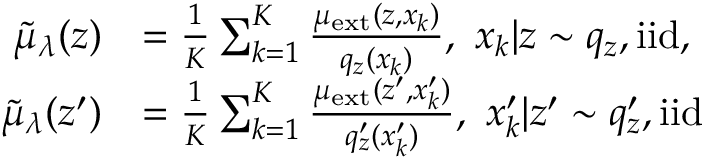<formula> <loc_0><loc_0><loc_500><loc_500>\begin{array} { r l } { \tilde { \mu } _ { \lambda } ( z ) } & { = \frac { 1 } { K } \sum _ { k = 1 } ^ { K } \frac { \mu _ { e x t } ( z , x _ { k } ) } { q _ { z } ( x _ { k } ) } , \ x _ { k } | z \sim q _ { z } , i i d , } \\ { \tilde { \mu } _ { \lambda } ( z ^ { \prime } ) } & { = \frac { 1 } { K } \sum _ { k = 1 } ^ { K } \frac { \mu _ { e x t } ( z ^ { \prime } , x _ { k } ^ { \prime } ) } { q _ { z } ^ { \prime } ( x _ { k } ^ { \prime } ) } , \ x _ { k } ^ { \prime } | z ^ { \prime } \sim q _ { z } ^ { \prime } , i i d } \end{array}</formula> 